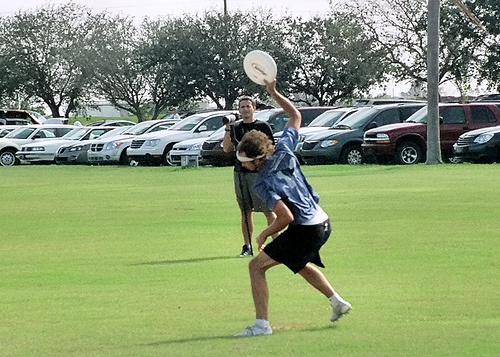Describe the objects in this image and their specific colors. I can see people in white, black, gray, maroon, and darkgray tones, car in white, black, gray, lightgray, and purple tones, car in white, black, lightgray, blue, and gray tones, people in white, black, and gray tones, and car in white, lightgray, black, darkgray, and lightblue tones in this image. 